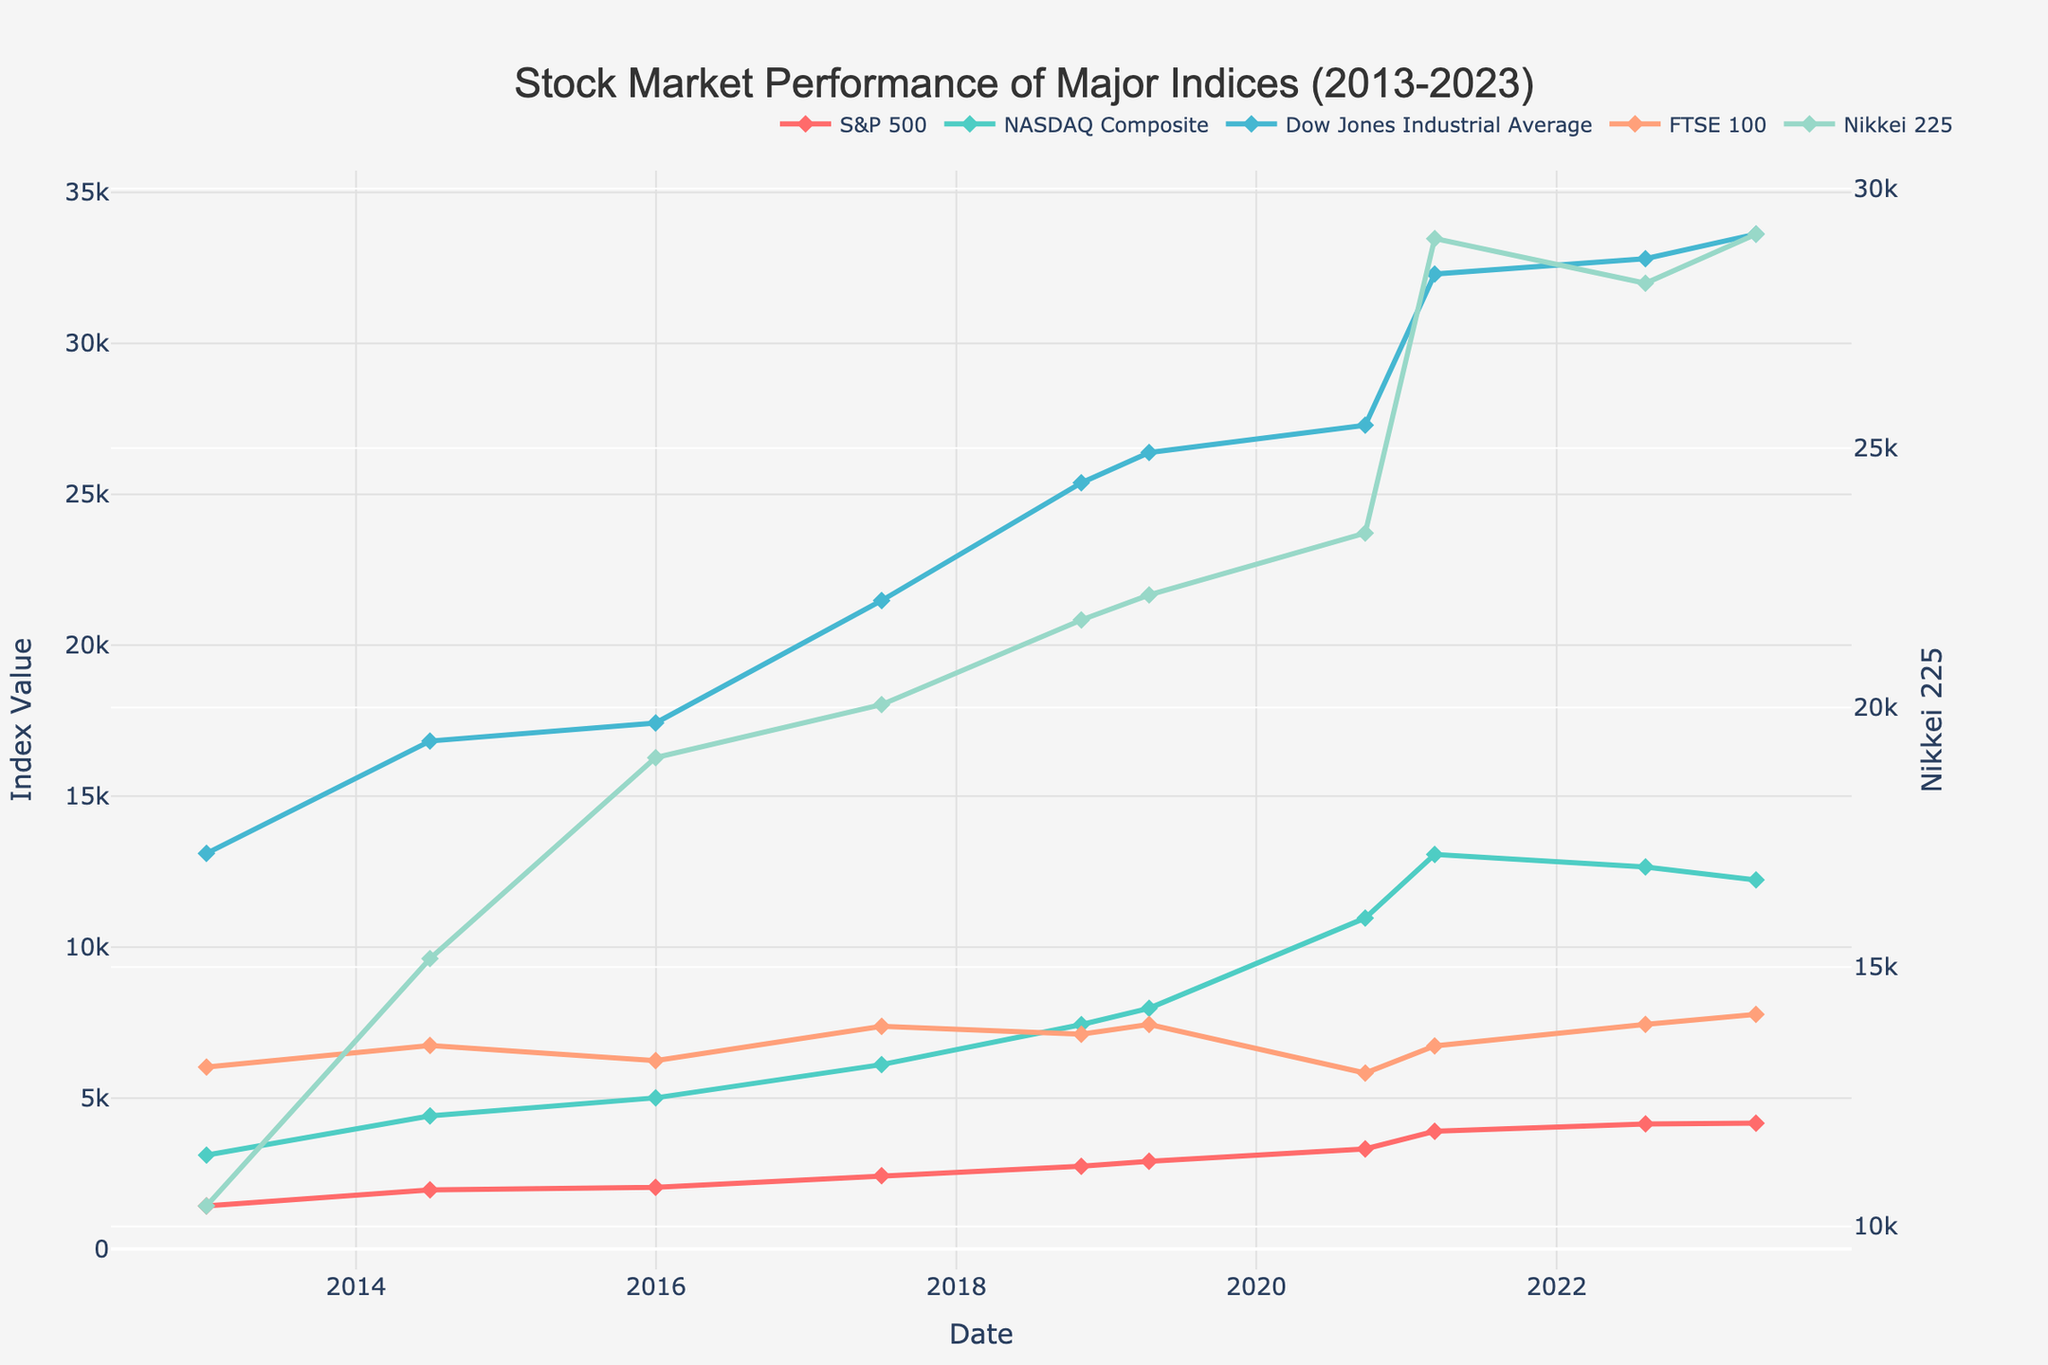What trend can be observed in the S&P 500 index over the decade? Observe the green line representing the S&P 500 index. It generally shows an upward trend from 2013 to 2023 with minor fluctuations, indicating growth in the market.
Answer: Upward trend Which index had the highest value as of 2023-05-01? Look at the date 2023-05-01 and compare the values of all indices. The Dow Jones Industrial Average had the highest value, above 33000.
Answer: Dow Jones Industrial Average Between which two dates did the NASDAQ Composite experience the most significant increase? Compare the NASDAQ Composite values between all consecutive dates. The largest noticeable increase is between 2018-11-01 (7434.06) and 2020-09-22 (10963.64).
Answer: Between 2018-11-01 and 2020-09-22 Which indices show a noticeable decline around 2020? Focus on the year 2020 across all indices. Both the FTSE 100 and Nikkei 225 show a noticeable decline around 2020.
Answer: FTSE 100 and Nikkei 225 What is the difference in value of the Dow Jones Industrial Average between the dates 2015-12-31 and 2023-05-01? Subtract the value of the Dow Jones on 2015-12-31 (17425.03) from its value on 2023-05-01 (33618.69). The difference is 16193.66.
Answer: 16193.66 How did the NASDAQ Composite perform relative to the Nikkei 225 on 2022-08-05? Compare the values of the NASDAQ Composite and Nikkei 225 on 2022-08-05. NASDAQ Composite (12657.55) is higher than Nikkei 225 (28175.87).
Answer: NASDAQ Composite is higher Which index had the lowest value as of 2020-09-22? Look at the values of all the indices on 2020-09-22. The FTSE 100 had the lowest value at 5829.46.
Answer: FTSE 100 What is the average value of the S&P 500 index in 2018 and 2019? Sum the values of the S&P 500 on 2018-11-01 (2740.37) and 2019-04-15 (2905.58) and then divide by 2. Average = (2740.37 + 2905.58)/2 = 2822.975
Answer: 2822.975 